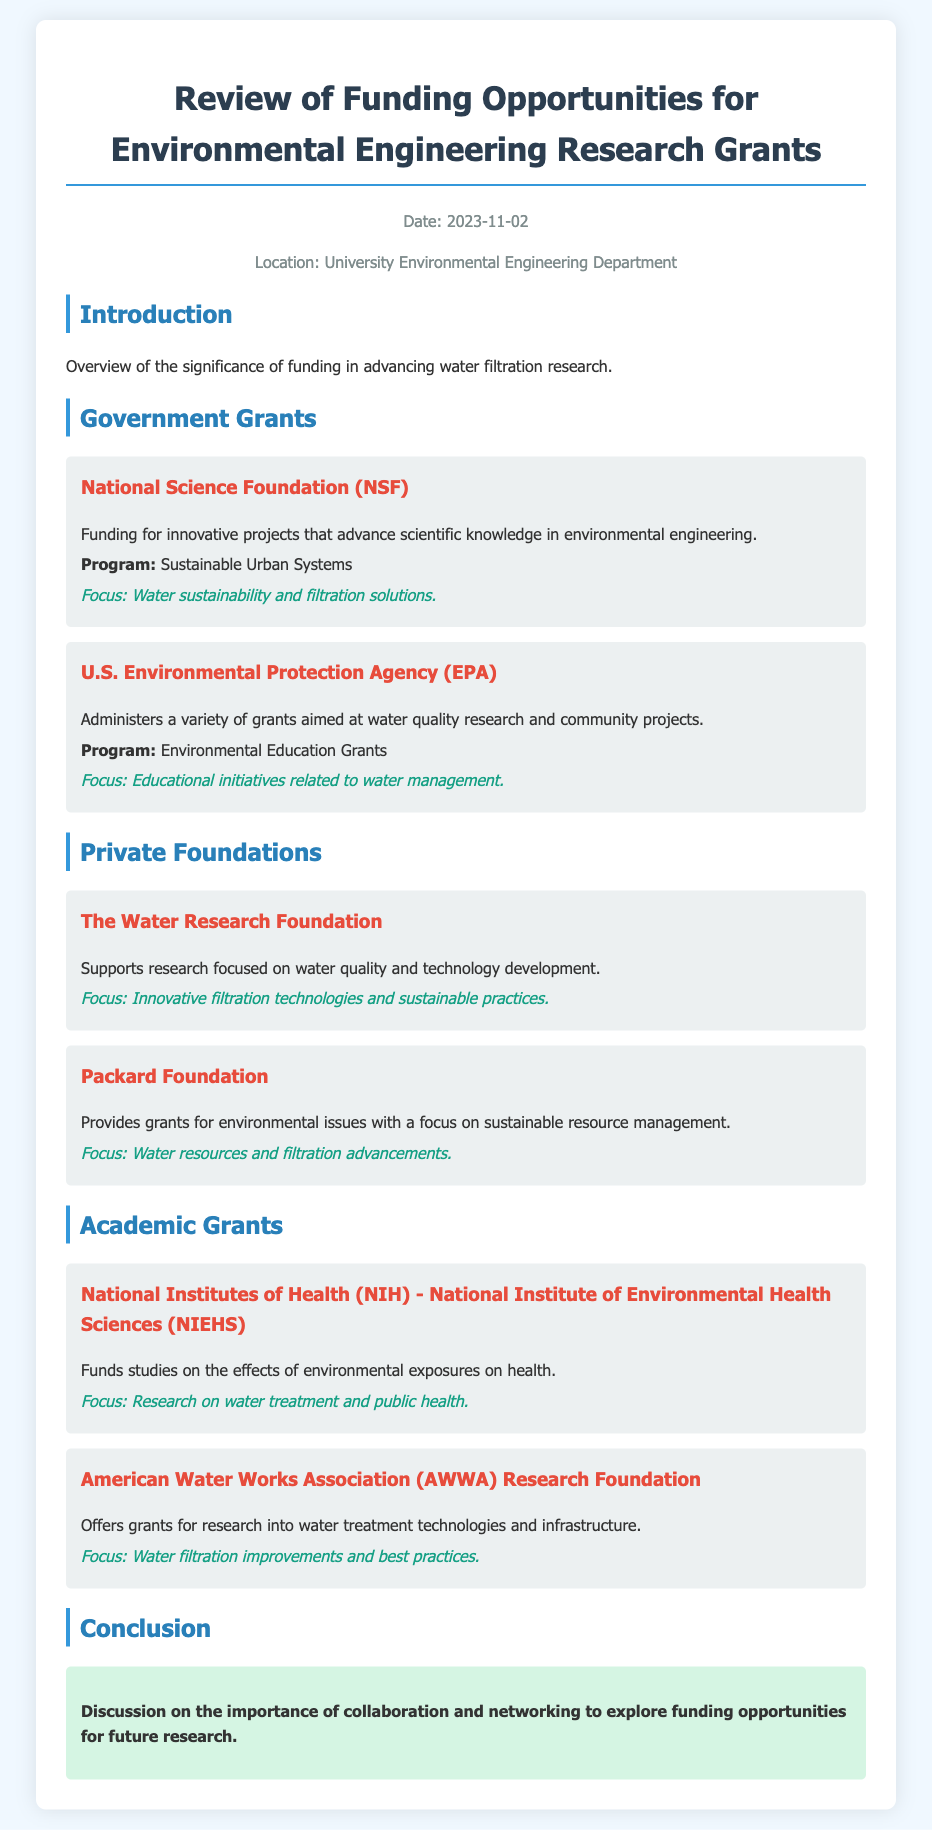what is the date of the review? The date mentioned in the document for the review of funding opportunities is 2023-11-02.
Answer: 2023-11-02 who administers the Environmental Education Grants? The document states that the U.S. Environmental Protection Agency (EPA) administers the Environmental Education Grants.
Answer: U.S. Environmental Protection Agency (EPA) what is the focus of the National Science Foundation funding? The document specifies that the focus of the National Science Foundation funding is on water sustainability and filtration solutions.
Answer: Water sustainability and filtration solutions which foundation supports research focused on water quality? According to the document, The Water Research Foundation supports research focused on water quality and technology development.
Answer: The Water Research Foundation what is one of the focuses of the Packard Foundation? The document indicates that one of the focuses of the Packard Foundation is on water resources and filtration advancements.
Answer: Water resources and filtration advancements what type of grants does the American Water Works Association provide? The document states that the American Water Works Association provides grants for research into water treatment technologies and infrastructure.
Answer: Water treatment technologies what is discussed in the conclusion of the document? The conclusion discusses the importance of collaboration and networking to explore funding opportunities for future research.
Answer: Importance of collaboration and networking how many government grant opportunities are listed? The document lists two government grant opportunities under the Government Grants section.
Answer: 2 